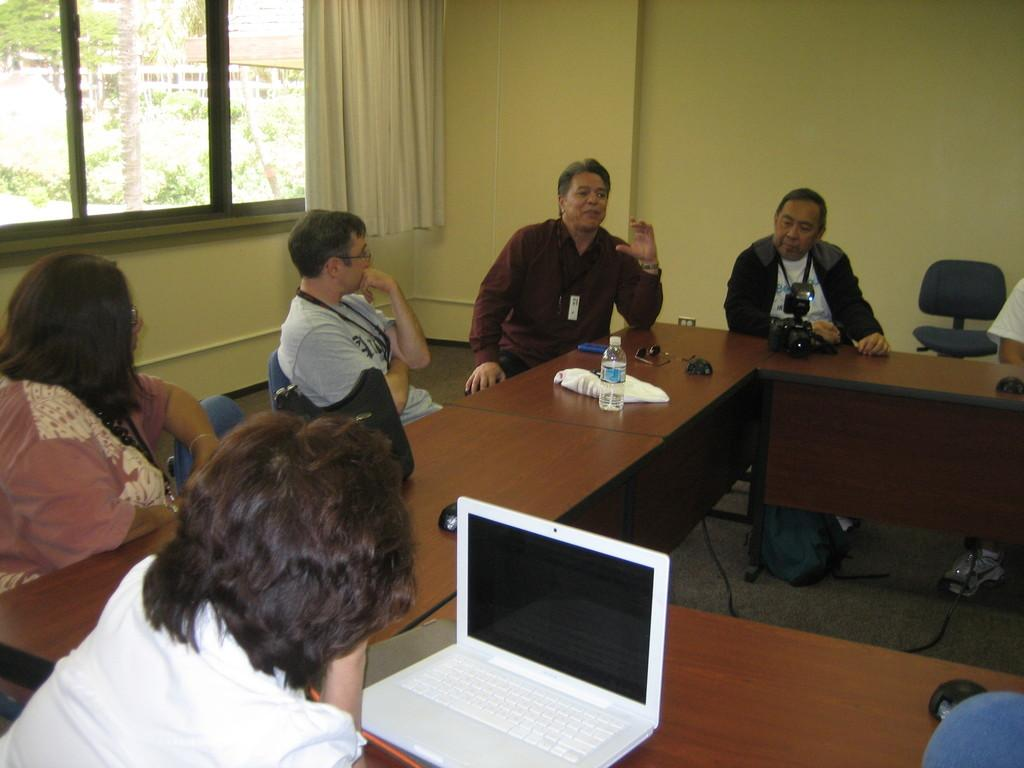What can be seen on the wall in the image? The wall has a yellow color. What is associated with the window in the image? There is a curtain associated with the window. What type of furniture is present in the image? There is a table and chairs in the image. What are the people in the image doing? There are people sitting on the chairs. What objects can be seen on the table in the image? There is a bottle and a laptop on the table. How does the scale in the image help the person with their stomach ache? There is no scale present in the image, and therefore it cannot help anyone with a stomach ache. What type of yard is visible through the window in the image? There is no yard visible through the window in the image; only a curtain is associated with the window. 